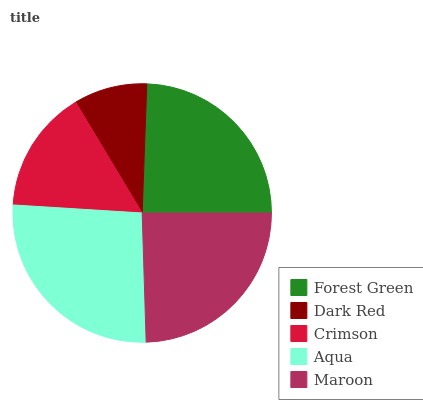Is Dark Red the minimum?
Answer yes or no. Yes. Is Aqua the maximum?
Answer yes or no. Yes. Is Crimson the minimum?
Answer yes or no. No. Is Crimson the maximum?
Answer yes or no. No. Is Crimson greater than Dark Red?
Answer yes or no. Yes. Is Dark Red less than Crimson?
Answer yes or no. Yes. Is Dark Red greater than Crimson?
Answer yes or no. No. Is Crimson less than Dark Red?
Answer yes or no. No. Is Forest Green the high median?
Answer yes or no. Yes. Is Forest Green the low median?
Answer yes or no. Yes. Is Aqua the high median?
Answer yes or no. No. Is Crimson the low median?
Answer yes or no. No. 